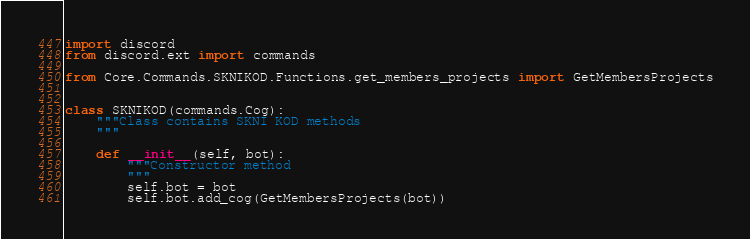<code> <loc_0><loc_0><loc_500><loc_500><_Python_>import discord
from discord.ext import commands

from Core.Commands.SKNIKOD.Functions.get_members_projects import GetMembersProjects


class SKNIKOD(commands.Cog):
    """Class contains SKNI KOD methods
    """

    def __init__(self, bot):
        """Constructor method
        """
        self.bot = bot
        self.bot.add_cog(GetMembersProjects(bot))
</code> 